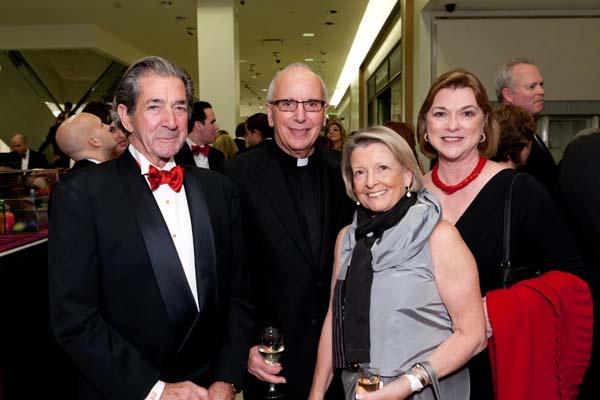Is anyone wearing a corsage?
Be succinct. No. Is the man wearing a bow tie or a regular tie?
Keep it brief. Bow tie. Where is the party?
Write a very short answer. Indoors. Are these people dressed for gardening?
Give a very brief answer. No. Is this a casual event?
Be succinct. No. What did the girl give to the man?
Answer briefly. Drink. How many people is in the photo?
Quick response, please. 4. Is that a red blanket?
Short answer required. No. Is the woman on the right wearing a solid color blouse?
Write a very short answer. Yes. 